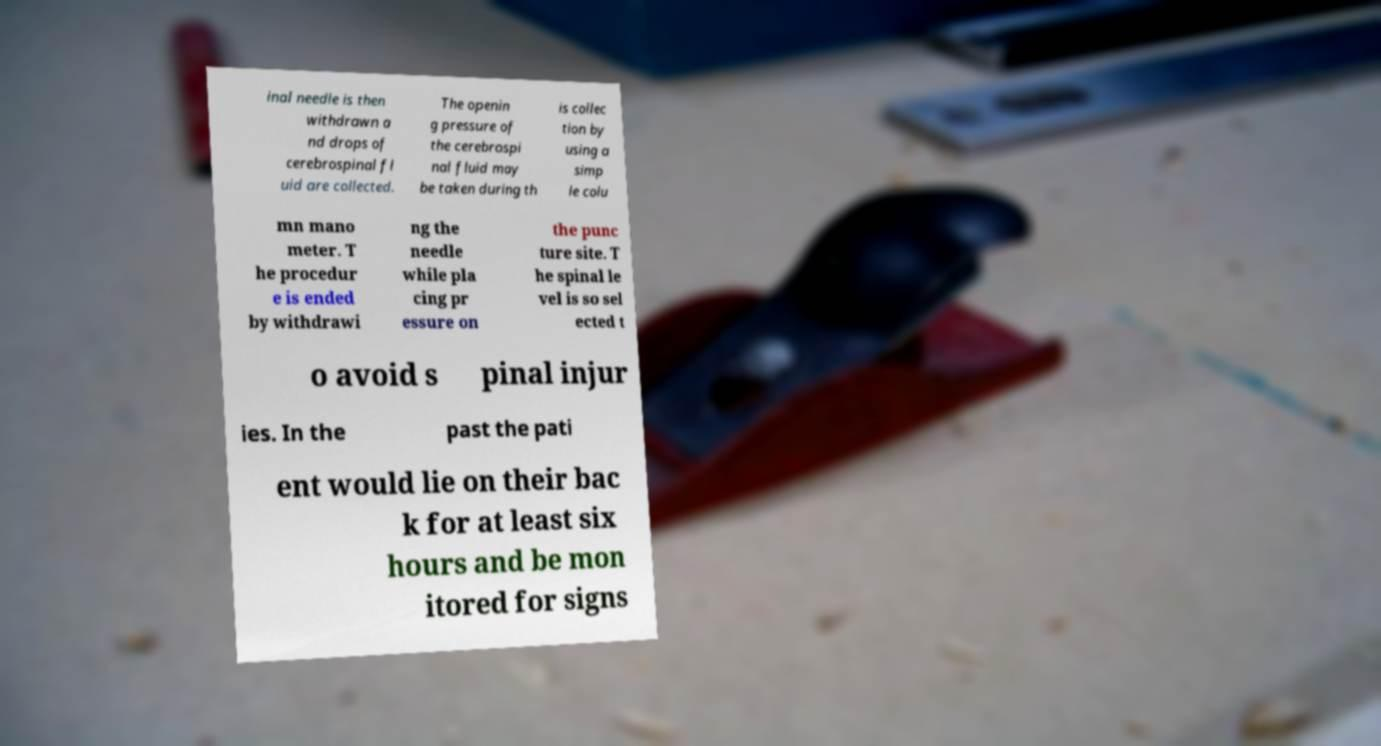Could you assist in decoding the text presented in this image and type it out clearly? inal needle is then withdrawn a nd drops of cerebrospinal fl uid are collected. The openin g pressure of the cerebrospi nal fluid may be taken during th is collec tion by using a simp le colu mn mano meter. T he procedur e is ended by withdrawi ng the needle while pla cing pr essure on the punc ture site. T he spinal le vel is so sel ected t o avoid s pinal injur ies. In the past the pati ent would lie on their bac k for at least six hours and be mon itored for signs 